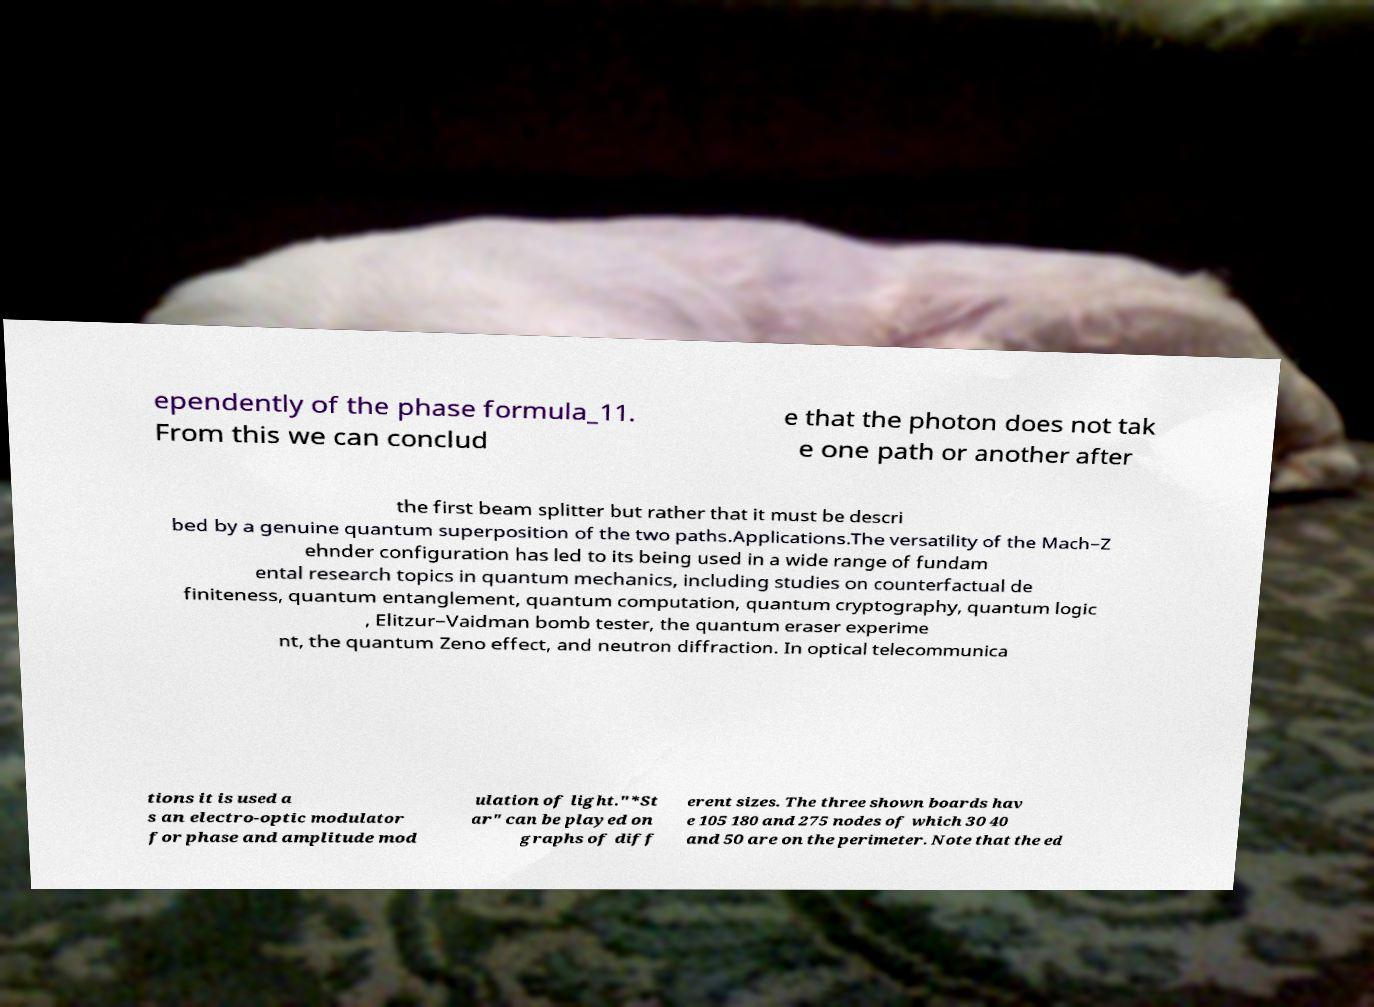Could you extract and type out the text from this image? ependently of the phase formula_11. From this we can conclud e that the photon does not tak e one path or another after the first beam splitter but rather that it must be descri bed by a genuine quantum superposition of the two paths.Applications.The versatility of the Mach–Z ehnder configuration has led to its being used in a wide range of fundam ental research topics in quantum mechanics, including studies on counterfactual de finiteness, quantum entanglement, quantum computation, quantum cryptography, quantum logic , Elitzur–Vaidman bomb tester, the quantum eraser experime nt, the quantum Zeno effect, and neutron diffraction. In optical telecommunica tions it is used a s an electro-optic modulator for phase and amplitude mod ulation of light."*St ar" can be played on graphs of diff erent sizes. The three shown boards hav e 105 180 and 275 nodes of which 30 40 and 50 are on the perimeter. Note that the ed 